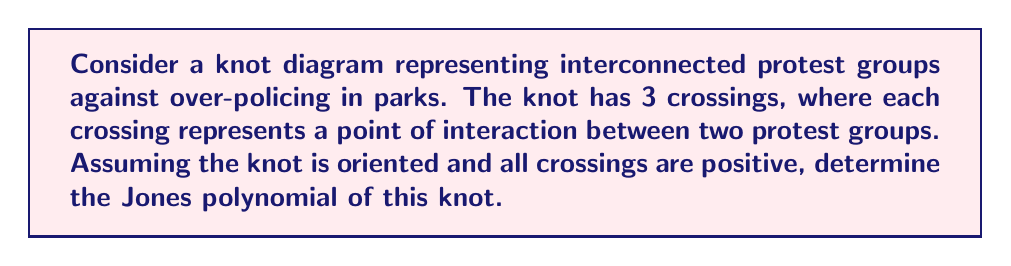Help me with this question. To find the Jones polynomial of this knot, we'll follow these steps:

1) First, recall that for a knot with $n$ positive crossings, the Jones polynomial is given by:

   $$V(t) = (-t^{1/2} - t^{-1/2})^{n-1}$$

2) In this case, we have 3 positive crossings, so $n = 3$.

3) Substituting $n = 3$ into the formula:

   $$V(t) = (-t^{1/2} - t^{-1/2})^{3-1} = (-t^{1/2} - t^{-1/2})^2$$

4) Expand the squared term:
   
   $$V(t) = (t^{1/2} + t^{-1/2})^2 + 2(t^{1/2} + t^{-1/2})(-t^{1/2} - t^{-1/2}) + (-t^{1/2} - t^{-1/2})^2$$

5) Simplify:

   $$V(t) = t + 2 + t^{-1} - 2(t + 2 + t^{-1}) + t + 2 + t^{-1}$$

6) Combine like terms:

   $$V(t) = t + 2 + t^{-1} - 2t - 4 - 2t^{-1} + t + 2 + t^{-1}$$

7) Final simplification:

   $$V(t) = -t^{-1} + 1 - t$$

This polynomial represents the topological properties of the knot formed by the interconnected protest groups, where each term corresponds to different levels of interaction between the groups.
Answer: $V(t) = -t^{-1} + 1 - t$ 